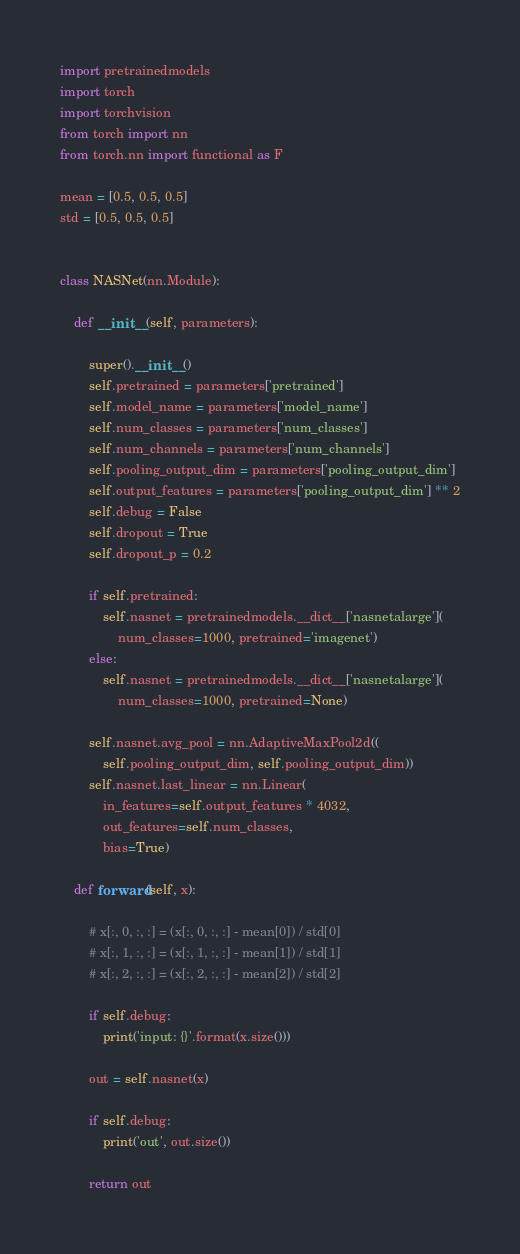<code> <loc_0><loc_0><loc_500><loc_500><_Python_>import pretrainedmodels
import torch
import torchvision
from torch import nn
from torch.nn import functional as F

mean = [0.5, 0.5, 0.5]
std = [0.5, 0.5, 0.5]


class NASNet(nn.Module):

    def __init__(self, parameters):

        super().__init__()
        self.pretrained = parameters['pretrained']
        self.model_name = parameters['model_name']
        self.num_classes = parameters['num_classes']
        self.num_channels = parameters['num_channels']
        self.pooling_output_dim = parameters['pooling_output_dim']
        self.output_features = parameters['pooling_output_dim'] ** 2
        self.debug = False
        self.dropout = True
        self.dropout_p = 0.2

        if self.pretrained:
            self.nasnet = pretrainedmodels.__dict__['nasnetalarge'](
                num_classes=1000, pretrained='imagenet')
        else:
            self.nasnet = pretrainedmodels.__dict__['nasnetalarge'](
                num_classes=1000, pretrained=None)

        self.nasnet.avg_pool = nn.AdaptiveMaxPool2d((
            self.pooling_output_dim, self.pooling_output_dim))
        self.nasnet.last_linear = nn.Linear(
            in_features=self.output_features * 4032,
            out_features=self.num_classes,
            bias=True)

    def forward(self, x):

        # x[:, 0, :, :] = (x[:, 0, :, :] - mean[0]) / std[0]
        # x[:, 1, :, :] = (x[:, 1, :, :] - mean[1]) / std[1]
        # x[:, 2, :, :] = (x[:, 2, :, :] - mean[2]) / std[2]

        if self.debug:
            print('input: {}'.format(x.size()))

        out = self.nasnet(x)

        if self.debug:
            print('out', out.size())

        return out
</code> 